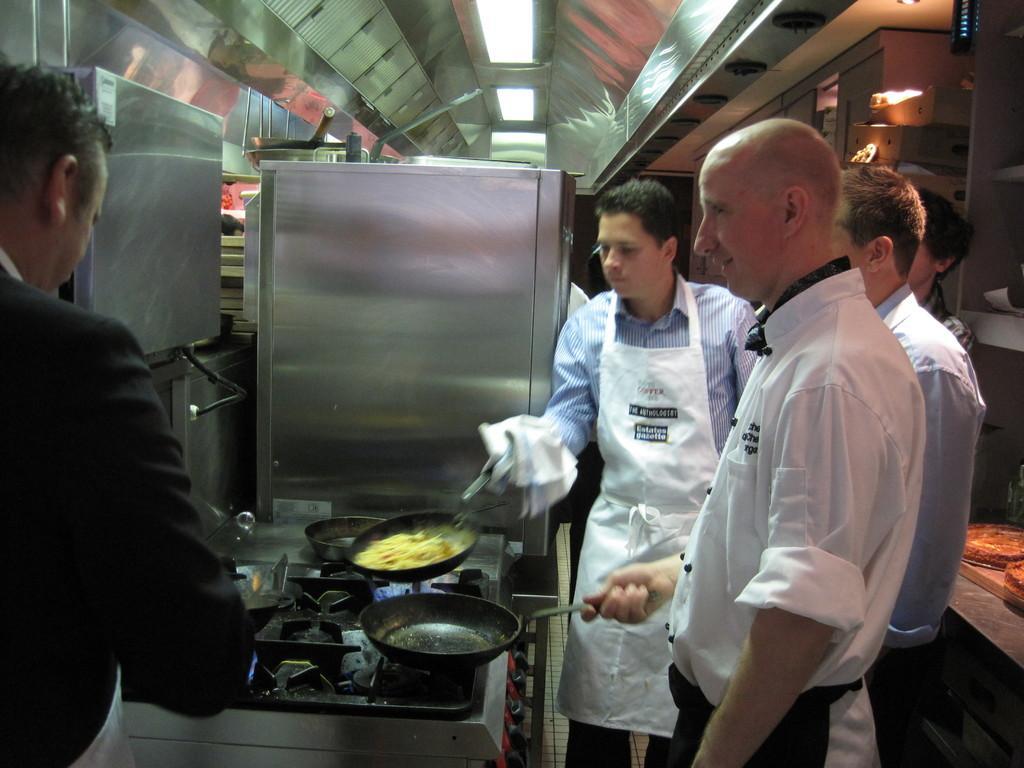Describe this image in one or two sentences. In this image there are chef holding vessels in their hands, in the middle there is a stove, at the top there is a ceiling. 